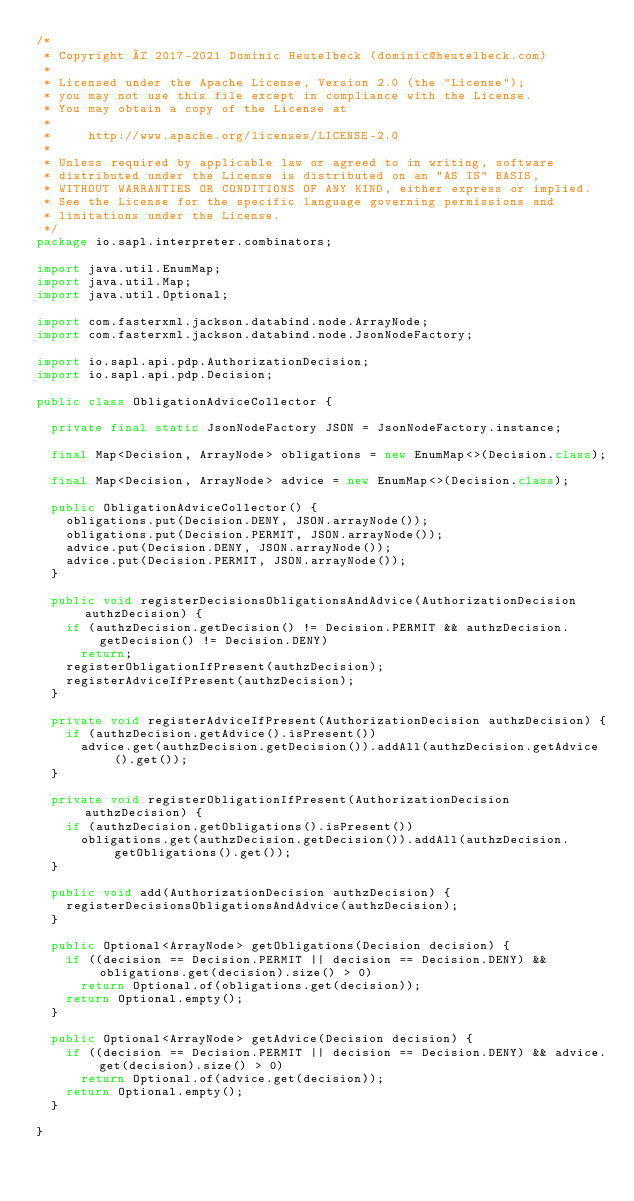Convert code to text. <code><loc_0><loc_0><loc_500><loc_500><_Java_>/*
 * Copyright © 2017-2021 Dominic Heutelbeck (dominic@heutelbeck.com)
 *
 * Licensed under the Apache License, Version 2.0 (the "License");
 * you may not use this file except in compliance with the License.
 * You may obtain a copy of the License at
 *
 *     http://www.apache.org/licenses/LICENSE-2.0
 *
 * Unless required by applicable law or agreed to in writing, software
 * distributed under the License is distributed on an "AS IS" BASIS,
 * WITHOUT WARRANTIES OR CONDITIONS OF ANY KIND, either express or implied.
 * See the License for the specific language governing permissions and
 * limitations under the License.
 */
package io.sapl.interpreter.combinators;

import java.util.EnumMap;
import java.util.Map;
import java.util.Optional;

import com.fasterxml.jackson.databind.node.ArrayNode;
import com.fasterxml.jackson.databind.node.JsonNodeFactory;

import io.sapl.api.pdp.AuthorizationDecision;
import io.sapl.api.pdp.Decision;

public class ObligationAdviceCollector {

	private final static JsonNodeFactory JSON = JsonNodeFactory.instance;

	final Map<Decision, ArrayNode> obligations = new EnumMap<>(Decision.class);

	final Map<Decision, ArrayNode> advice = new EnumMap<>(Decision.class);

	public ObligationAdviceCollector() {
		obligations.put(Decision.DENY, JSON.arrayNode());
		obligations.put(Decision.PERMIT, JSON.arrayNode());
		advice.put(Decision.DENY, JSON.arrayNode());
		advice.put(Decision.PERMIT, JSON.arrayNode());
	}

	public void registerDecisionsObligationsAndAdvice(AuthorizationDecision authzDecision) {
		if (authzDecision.getDecision() != Decision.PERMIT && authzDecision.getDecision() != Decision.DENY)
			return;
		registerObligationIfPresent(authzDecision);
		registerAdviceIfPresent(authzDecision);
	}

	private void registerAdviceIfPresent(AuthorizationDecision authzDecision) {
		if (authzDecision.getAdvice().isPresent())
			advice.get(authzDecision.getDecision()).addAll(authzDecision.getAdvice().get());
	}

	private void registerObligationIfPresent(AuthorizationDecision authzDecision) {
		if (authzDecision.getObligations().isPresent())
			obligations.get(authzDecision.getDecision()).addAll(authzDecision.getObligations().get());
	}

	public void add(AuthorizationDecision authzDecision) {
		registerDecisionsObligationsAndAdvice(authzDecision);
	}

	public Optional<ArrayNode> getObligations(Decision decision) {
		if ((decision == Decision.PERMIT || decision == Decision.DENY) && obligations.get(decision).size() > 0)
			return Optional.of(obligations.get(decision));
		return Optional.empty();
	}

	public Optional<ArrayNode> getAdvice(Decision decision) {
		if ((decision == Decision.PERMIT || decision == Decision.DENY) && advice.get(decision).size() > 0)
			return Optional.of(advice.get(decision));
		return Optional.empty();
	}

}
</code> 